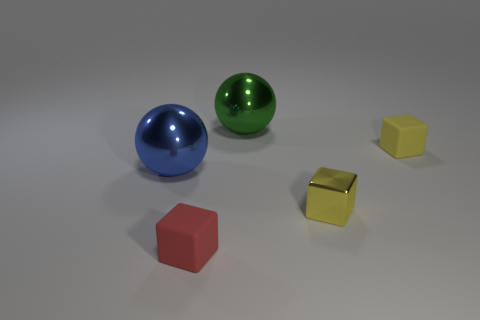Add 4 big blue metal things. How many objects exist? 9 Subtract all balls. How many objects are left? 3 Subtract 1 blue spheres. How many objects are left? 4 Subtract all small yellow rubber things. Subtract all big green metallic spheres. How many objects are left? 3 Add 5 small yellow objects. How many small yellow objects are left? 7 Add 2 big brown blocks. How many big brown blocks exist? 2 